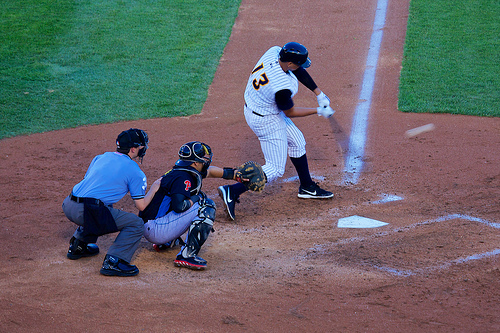Is the person with the helmet wearing a cap? No, the person with the helmet, focused on batting, is not wearing an additional cap under or over the helmet. 